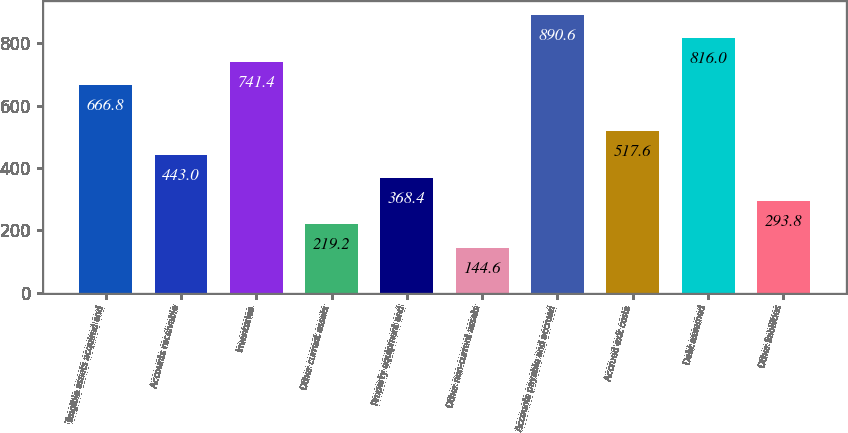Convert chart to OTSL. <chart><loc_0><loc_0><loc_500><loc_500><bar_chart><fcel>Tangible assets acquired and<fcel>Accounts receivable<fcel>Inventories<fcel>Other current assets<fcel>Property equipment and<fcel>Other non-current assets<fcel>Accounts payable and accrued<fcel>Accrued exit costs<fcel>Debt assumed<fcel>Other liabilities<nl><fcel>666.8<fcel>443<fcel>741.4<fcel>219.2<fcel>368.4<fcel>144.6<fcel>890.6<fcel>517.6<fcel>816<fcel>293.8<nl></chart> 